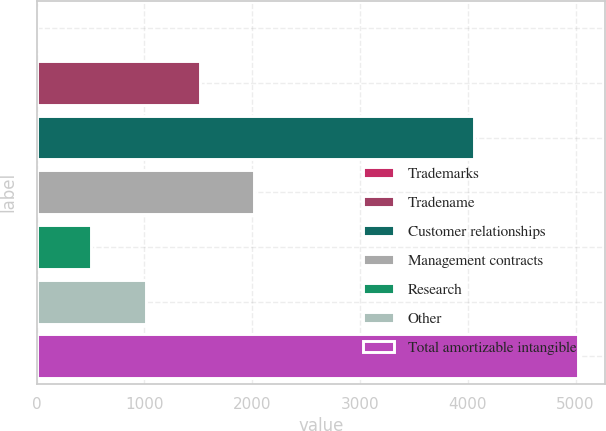Convert chart. <chart><loc_0><loc_0><loc_500><loc_500><bar_chart><fcel>Trademarks<fcel>Tradename<fcel>Customer relationships<fcel>Management contracts<fcel>Research<fcel>Other<fcel>Total amortizable intangible<nl><fcel>7<fcel>1512.7<fcel>4058<fcel>2014.6<fcel>508.9<fcel>1010.8<fcel>5026<nl></chart> 